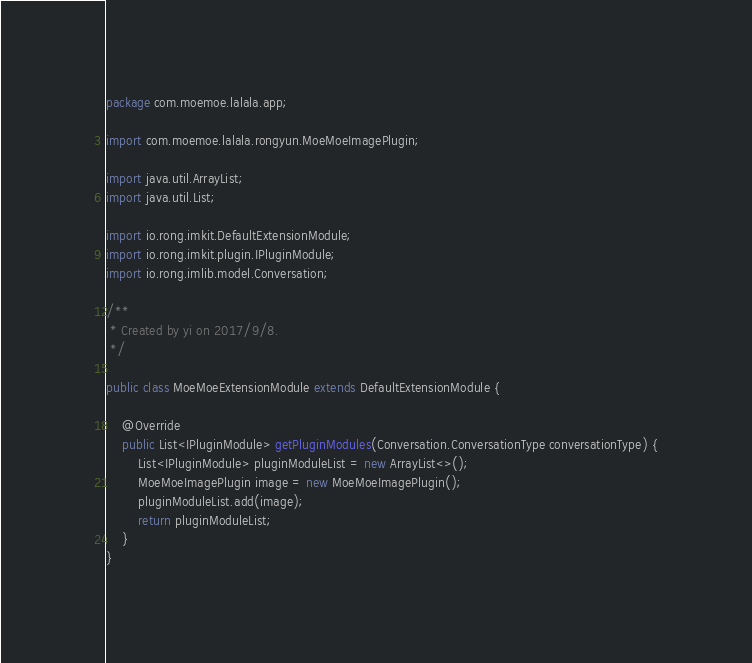Convert code to text. <code><loc_0><loc_0><loc_500><loc_500><_Java_>package com.moemoe.lalala.app;

import com.moemoe.lalala.rongyun.MoeMoeImagePlugin;

import java.util.ArrayList;
import java.util.List;

import io.rong.imkit.DefaultExtensionModule;
import io.rong.imkit.plugin.IPluginModule;
import io.rong.imlib.model.Conversation;

/**
 * Created by yi on 2017/9/8.
 */

public class MoeMoeExtensionModule extends DefaultExtensionModule {

    @Override
    public List<IPluginModule> getPluginModules(Conversation.ConversationType conversationType) {
        List<IPluginModule> pluginModuleList = new ArrayList<>();
        MoeMoeImagePlugin image = new MoeMoeImagePlugin();
        pluginModuleList.add(image);
        return pluginModuleList;
    }
}
</code> 